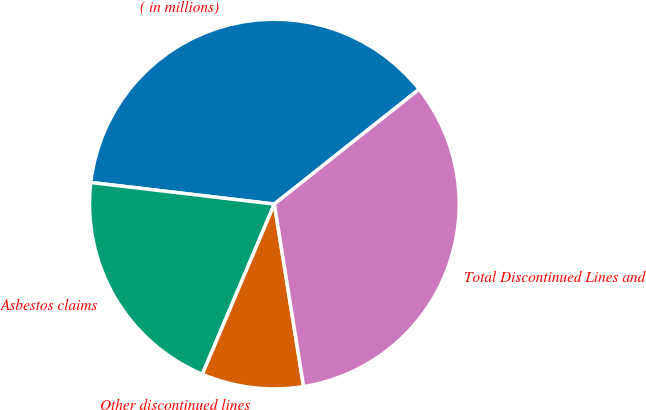Convert chart to OTSL. <chart><loc_0><loc_0><loc_500><loc_500><pie_chart><fcel>( in millions)<fcel>Asbestos claims<fcel>Other discontinued lines<fcel>Total Discontinued Lines and<nl><fcel>37.46%<fcel>20.49%<fcel>8.9%<fcel>33.14%<nl></chart> 